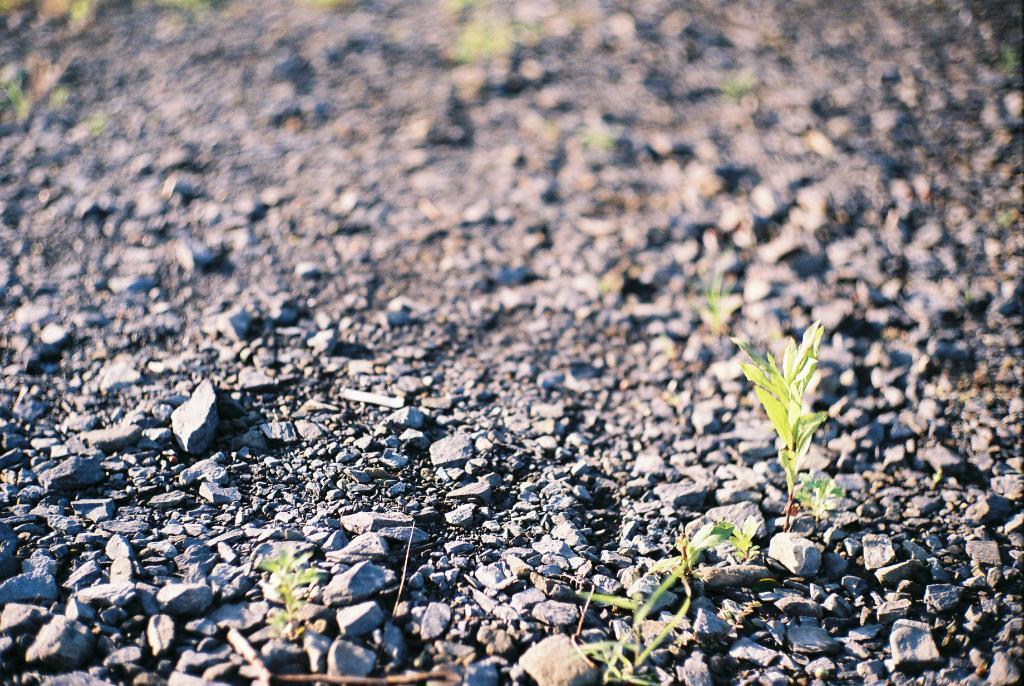Describe this image in one or two sentences. In this picture, we can see ground with stones, plants, and the blurred background. 